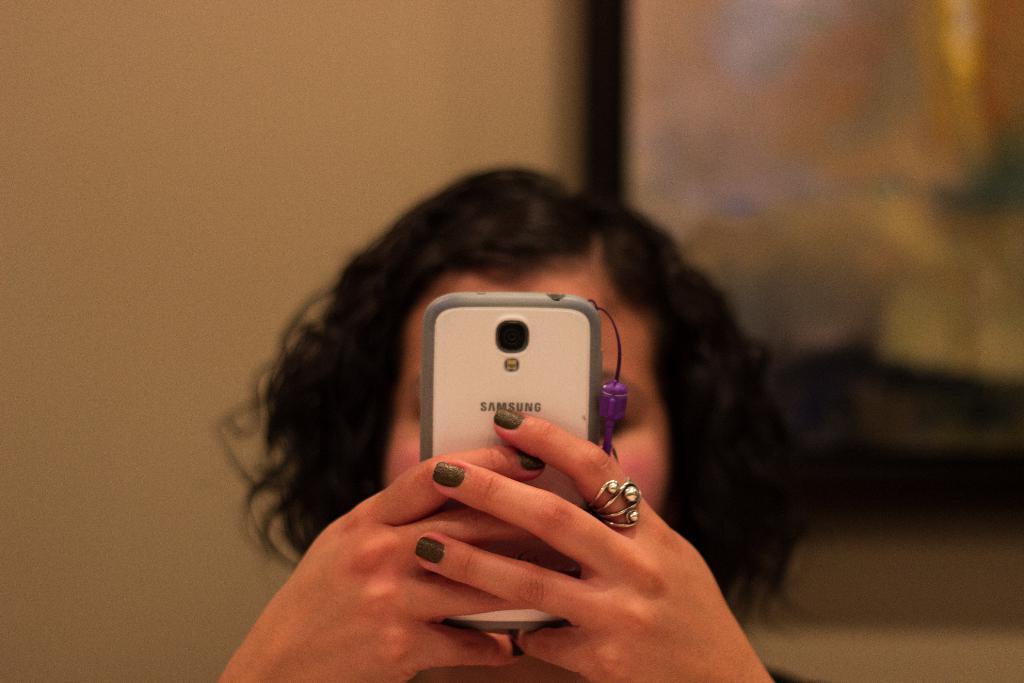In one or two sentences, can you explain what this image depicts? In the middle of this image, there is a woman having a ring on her finger and holding a mobile with both hands. And the background is blurred. 